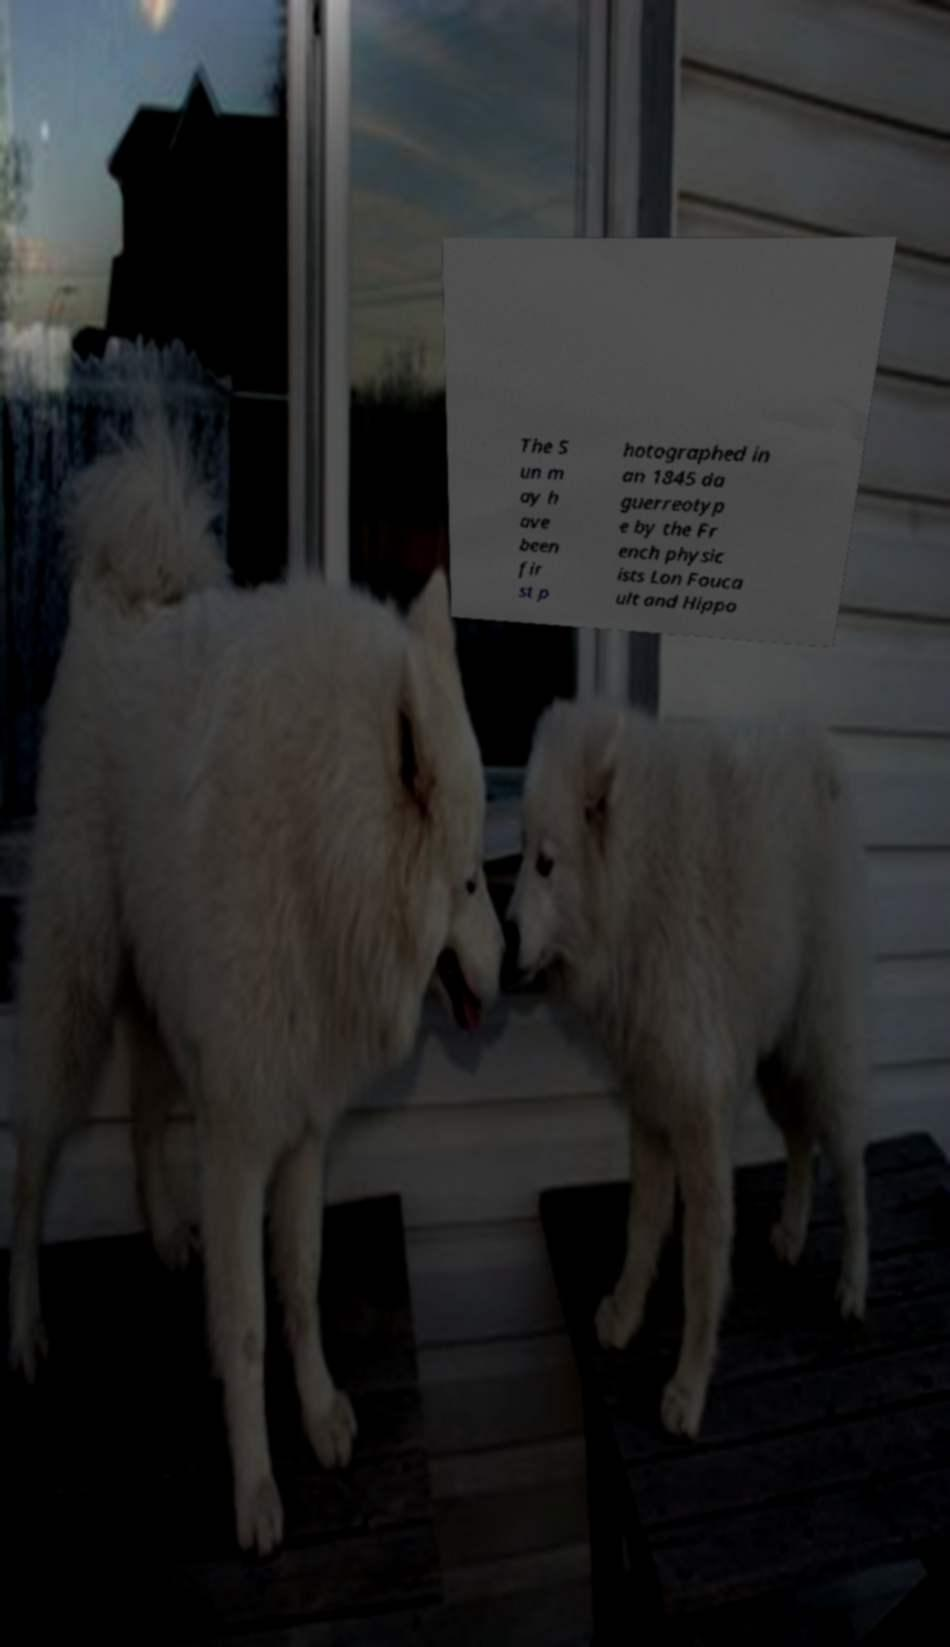Could you assist in decoding the text presented in this image and type it out clearly? The S un m ay h ave been fir st p hotographed in an 1845 da guerreotyp e by the Fr ench physic ists Lon Fouca ult and Hippo 